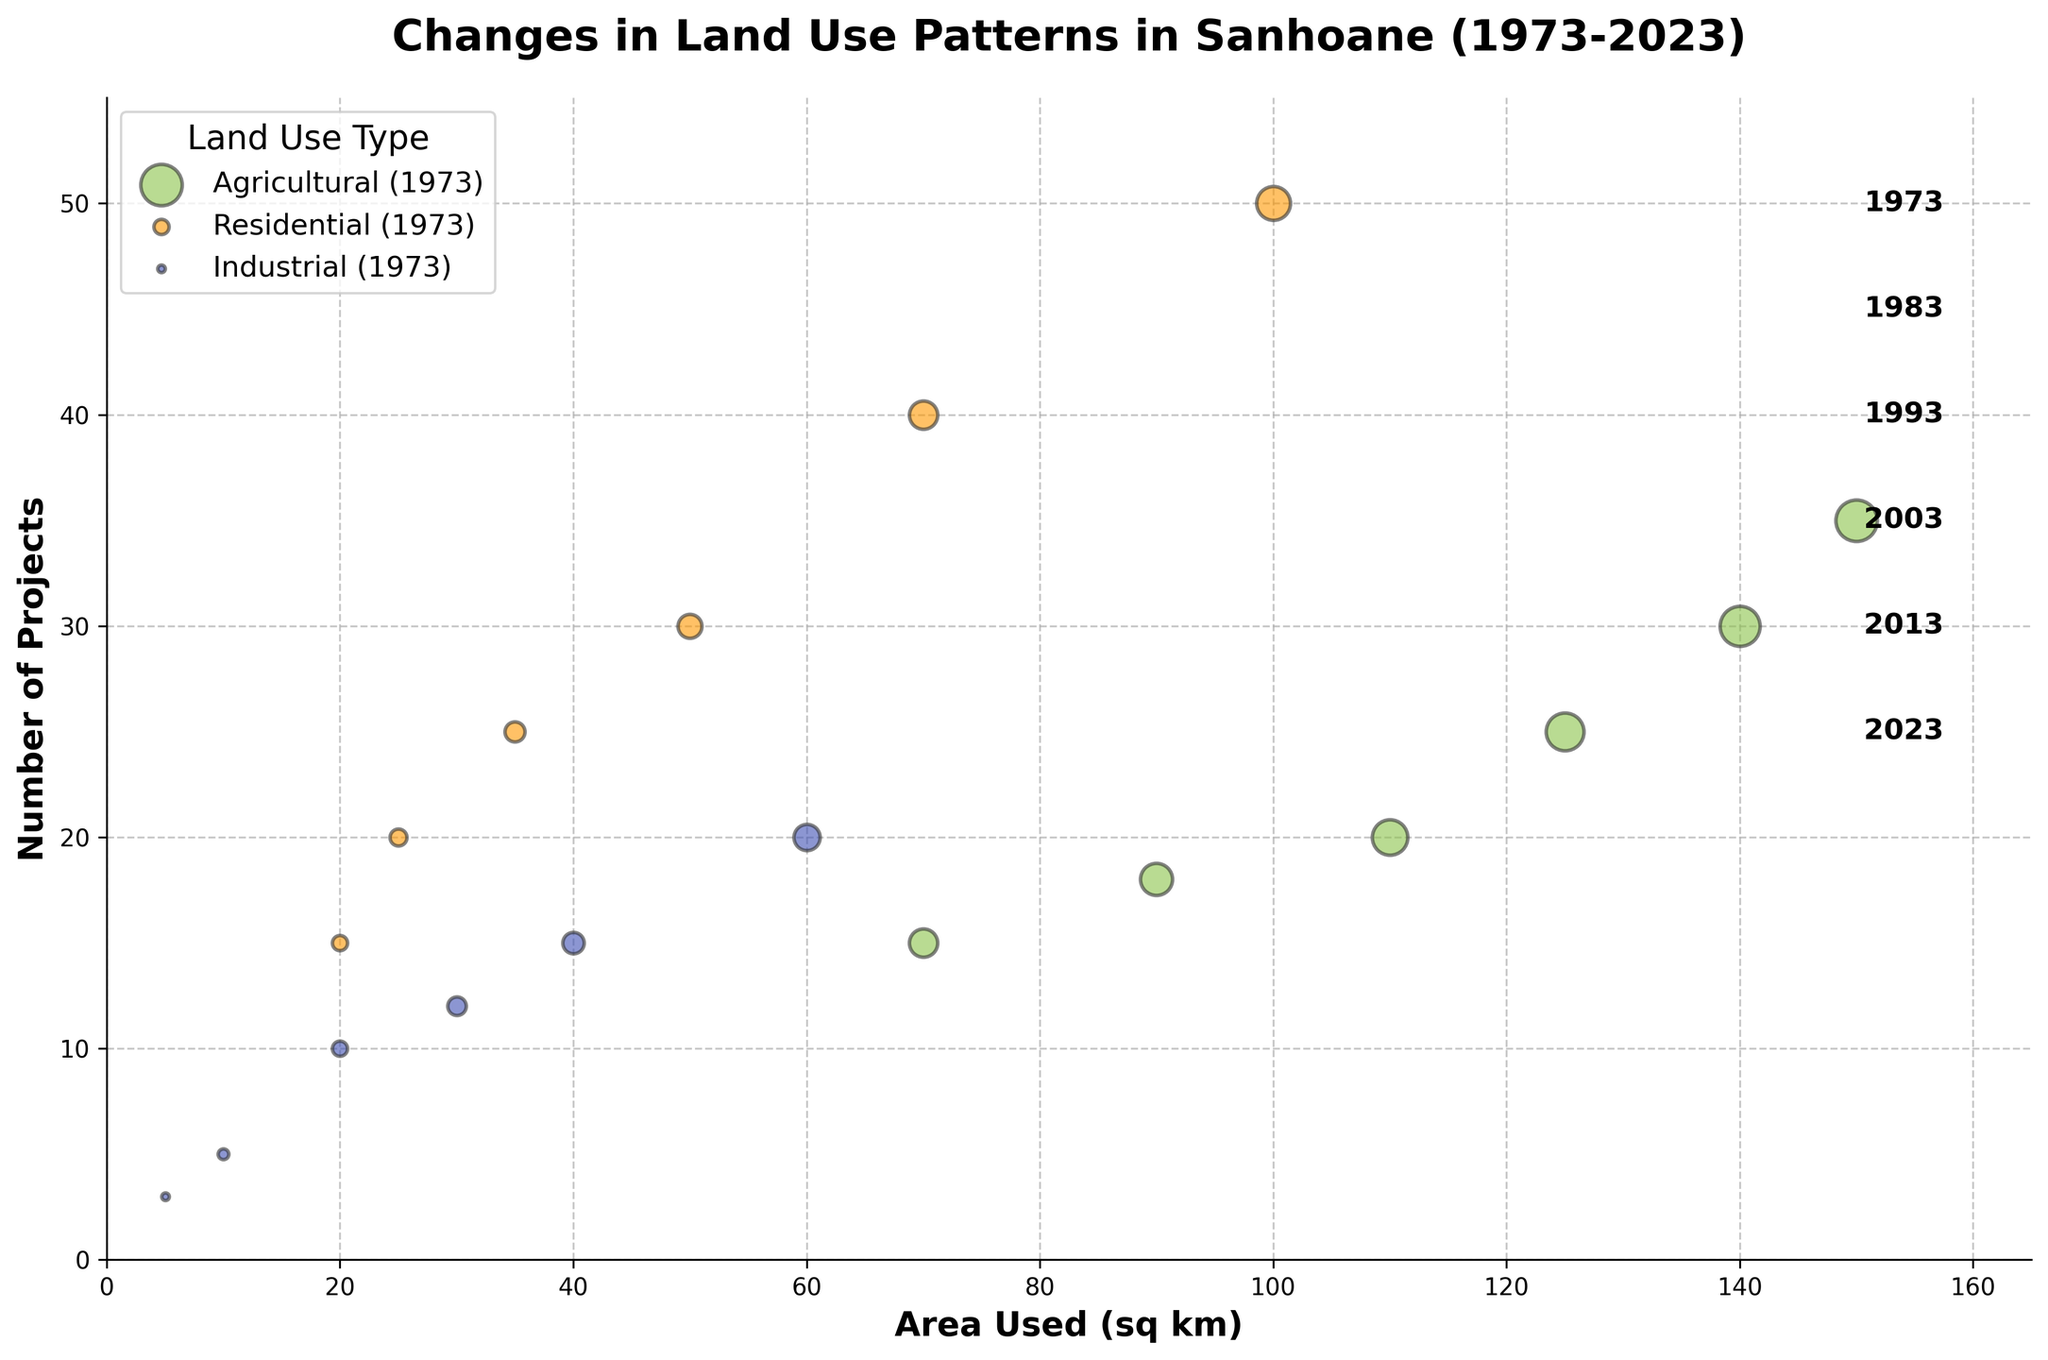What is the title of the figure? The title of the figure is located at the top and provides an overview of the data being presented. In this case, the title is "Changes in Land Use Patterns in Sanhoane (1973-2023)."
Answer: Changes in Land Use Patterns in Sanhoane (1973-2023) Which color represents Agricultural land use? The legend indicates the colors used for each land use type. Agricultural land use is represented by a light green shade.
Answer: Light green How many data points are there for the year 1993? Each data point represents a land use type for a given year. Looking at the chart, we see that there are three distinct bubbles for the year 1993: one for Agricultural, one for Residential, and one for Industrial.
Answer: 3 What is the maximum number of projects recorded in any year for any land use type? By examining the vertical axis (Number of Projects) and looking for the highest point reached by any bubble, we see that the year with the peak number of projects is 2023 for Residential use, which reaches 50 projects.
Answer: 50 How has the area used for Industrial land changed from 1973 to 2023? We need to compare the x-coordinates of the Industrial land use bubbles from 1973 and 2023. In 1973, Industrial land used was 5 sq km, and it increased to 60 sq km by 2023.
Answer: Increased by 55 sq km Which land use type had the highest increase in number of projects between 1973 and 2023? By looking at the vertical changes in the Residential, Industrial, and Agricultural bubbles from 1973 to 2023, we see that Residential use increased from 15 projects in 1973 to 50 projects in 2023, which is the highest increase among the land use types.
Answer: Residential Compare the size of the Agricultural area used in 1983 to that in 2003. The size of each bubble represents the area used. By comparing the x-coordinates of Agricultural land in 1983 (140 sq km) and 2003 (110 sq km), we see a reduction over the years.
Answer: Decreased by 30 sq km What trend can be observed in the Residential land area from 1973 to 2023? Observing the x-coordinates of Residential land bubbles over the years, we notice a consistent increase: from 20 sq km in 1973 to 100 sq km in 2023.
Answer: Increasing trend Which year had the least Agricultural projects, and how many were there? By checking the vertical positions of Agricultural bubbles across all years, the year 2023 had the least number of projects with 15.
Answer: 2023 with 15 projects How does the number of Residential projects in 2003 compare to that in 1983? We compare the y-coordinates for Residential bubbles of 1983 and 2003. In 1983, there were 20 projects, and in 2003, there were 30 projects, indicating an increase.
Answer: Increased by 10 projects 